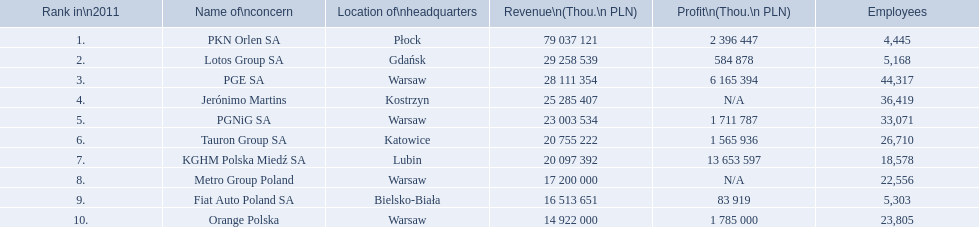What are the designations of all the apprehensions? PKN Orlen SA, Lotos Group SA, PGE SA, Jerónimo Martins, PGNiG SA, Tauron Group SA, KGHM Polska Miedź SA, Metro Group Poland, Fiat Auto Poland SA, Orange Polska. How many staff members does pgnig sa have? 33,071. 